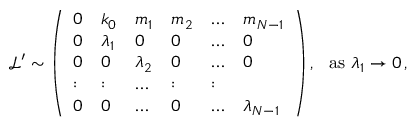<formula> <loc_0><loc_0><loc_500><loc_500>\begin{array} { r } { \ \mathcal { L } ^ { \prime } \sim \left ( \begin{array} { l l l l l l } { 0 } & { k _ { 0 } } & { m _ { 1 } } & { m _ { 2 } } & { \dots } & { m _ { N - 1 } } \\ { 0 } & { \lambda _ { 1 } } & { 0 } & { 0 } & { \dots } & { 0 } \\ { 0 } & { 0 } & { \lambda _ { 2 } } & { 0 } & { \dots } & { 0 } \\ { \colon } & { \colon } & { \dots } & { \colon } & { \colon } \\ { 0 } & { 0 } & { \dots } & { 0 } & { \dots } & { \lambda _ { N - 1 } } \end{array} \right ) , a s \lambda _ { 1 } \rightarrow 0 \, , } \end{array}</formula> 